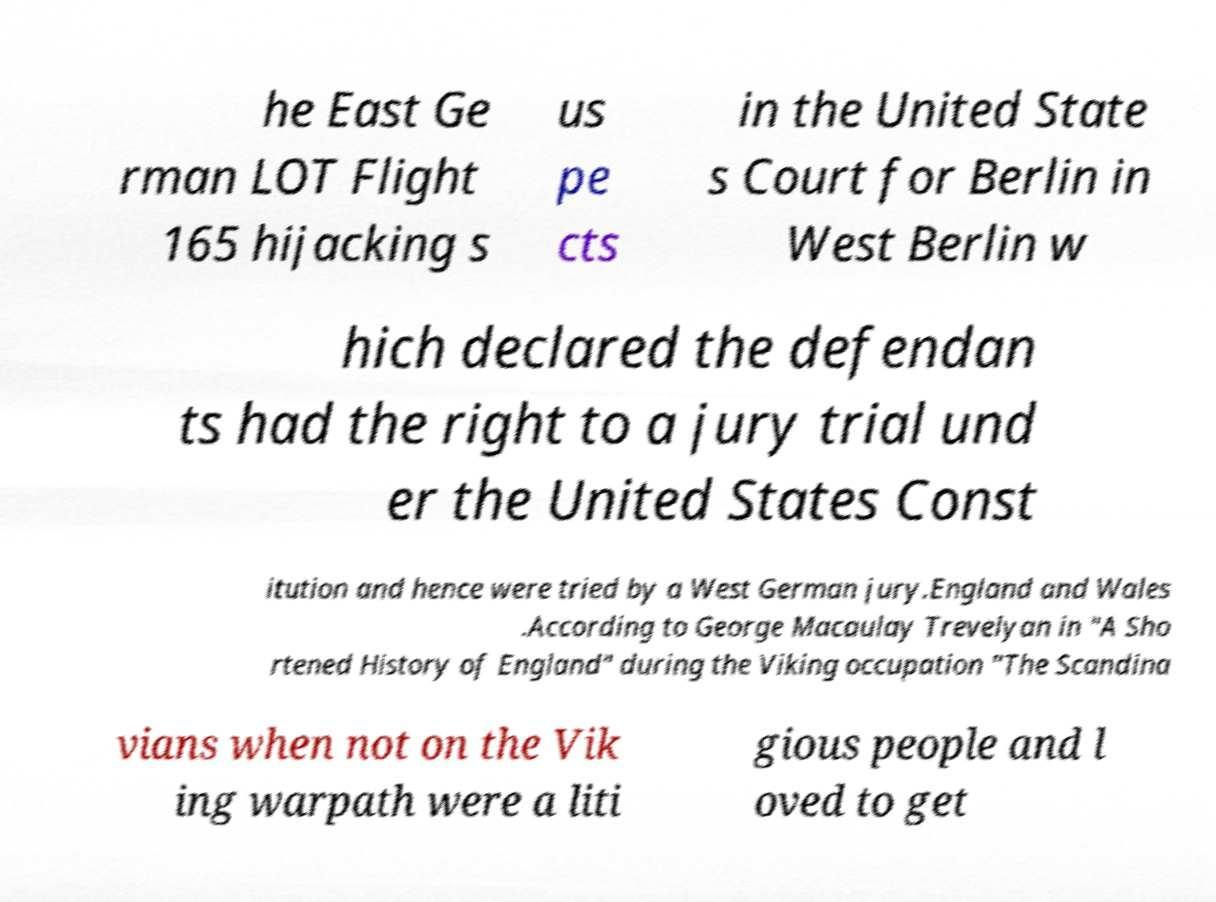For documentation purposes, I need the text within this image transcribed. Could you provide that? he East Ge rman LOT Flight 165 hijacking s us pe cts in the United State s Court for Berlin in West Berlin w hich declared the defendan ts had the right to a jury trial und er the United States Const itution and hence were tried by a West German jury.England and Wales .According to George Macaulay Trevelyan in "A Sho rtened History of England" during the Viking occupation "The Scandina vians when not on the Vik ing warpath were a liti gious people and l oved to get 